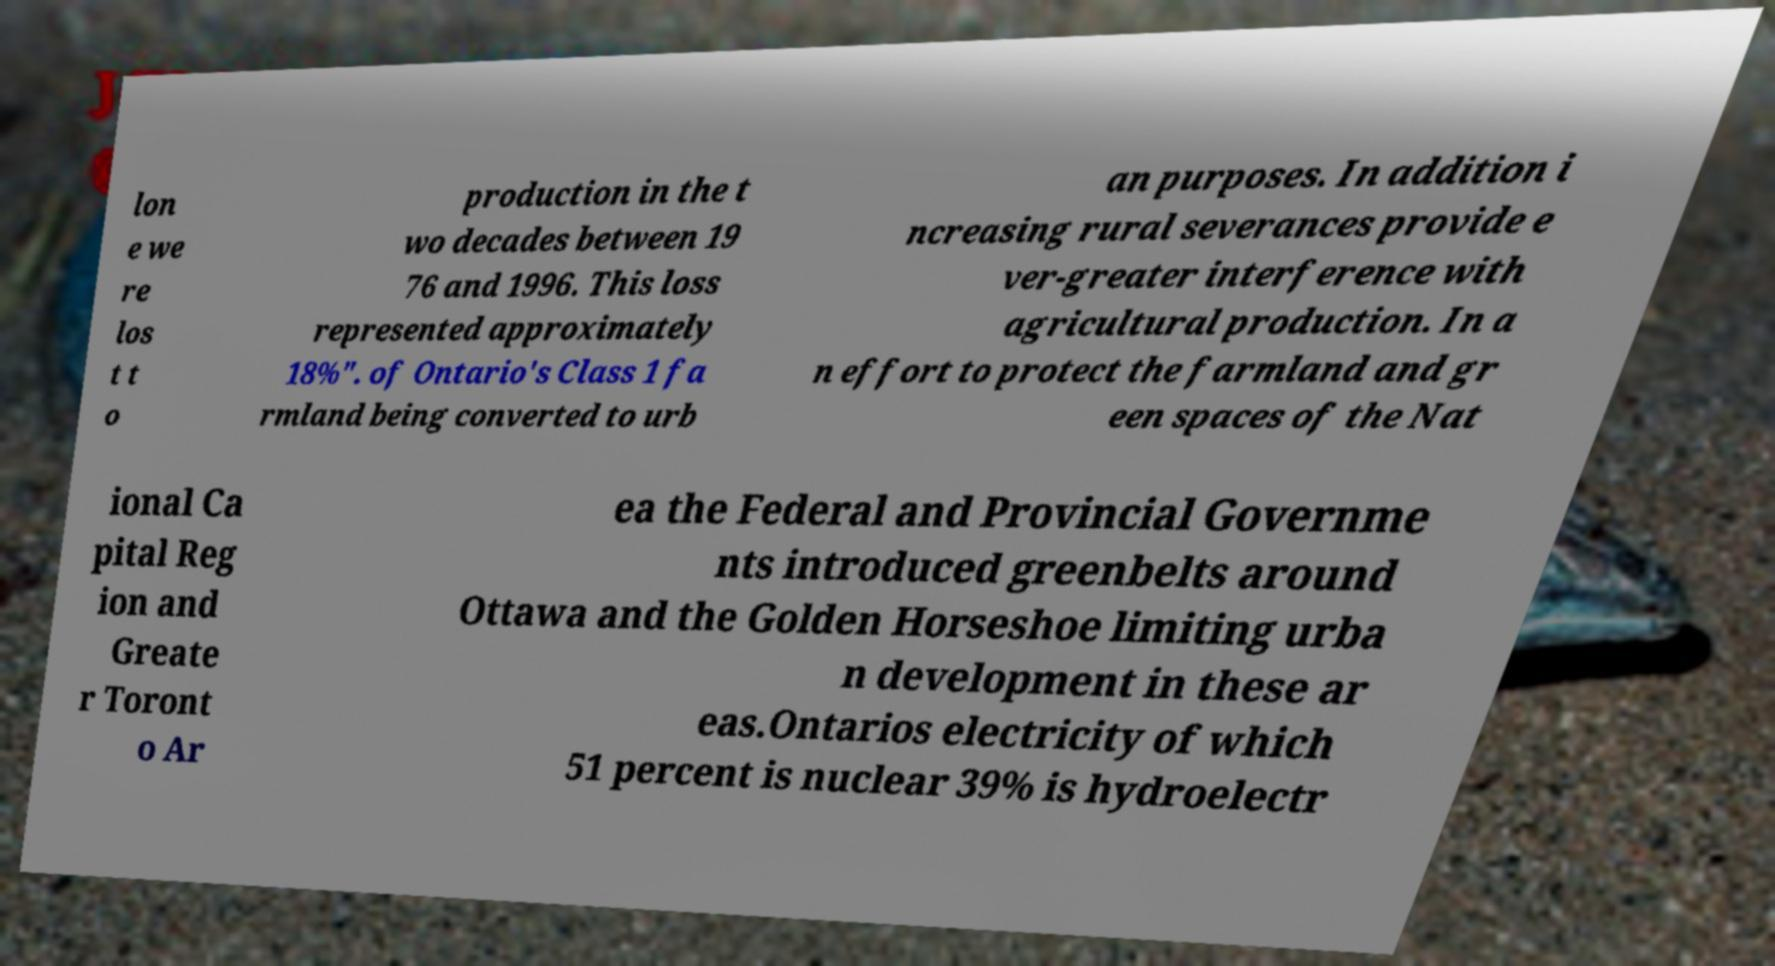Could you assist in decoding the text presented in this image and type it out clearly? lon e we re los t t o production in the t wo decades between 19 76 and 1996. This loss represented approximately 18%". of Ontario's Class 1 fa rmland being converted to urb an purposes. In addition i ncreasing rural severances provide e ver-greater interference with agricultural production. In a n effort to protect the farmland and gr een spaces of the Nat ional Ca pital Reg ion and Greate r Toront o Ar ea the Federal and Provincial Governme nts introduced greenbelts around Ottawa and the Golden Horseshoe limiting urba n development in these ar eas.Ontarios electricity of which 51 percent is nuclear 39% is hydroelectr 